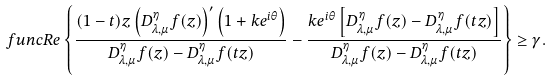<formula> <loc_0><loc_0><loc_500><loc_500>\ f u n c { R e } \left \{ \frac { ( 1 - t ) z \left ( D _ { \lambda , \mu } ^ { \eta } f ( z ) \right ) ^ { \prime } \left ( 1 + k e ^ { i \theta } \right ) } { D _ { \lambda , \mu } ^ { \eta } f ( z ) - D _ { \lambda , \mu } ^ { \eta } f ( t z ) } - \frac { k e ^ { i \theta } \left [ D _ { \lambda , \mu } ^ { \eta } f ( z ) - D _ { \lambda , \mu } ^ { \eta } f ( t z ) \right ] } { D _ { \lambda , \mu } ^ { \eta } f ( z ) - D _ { \lambda , \mu } ^ { \eta } f ( t z ) } \right \} \geq \gamma .</formula> 